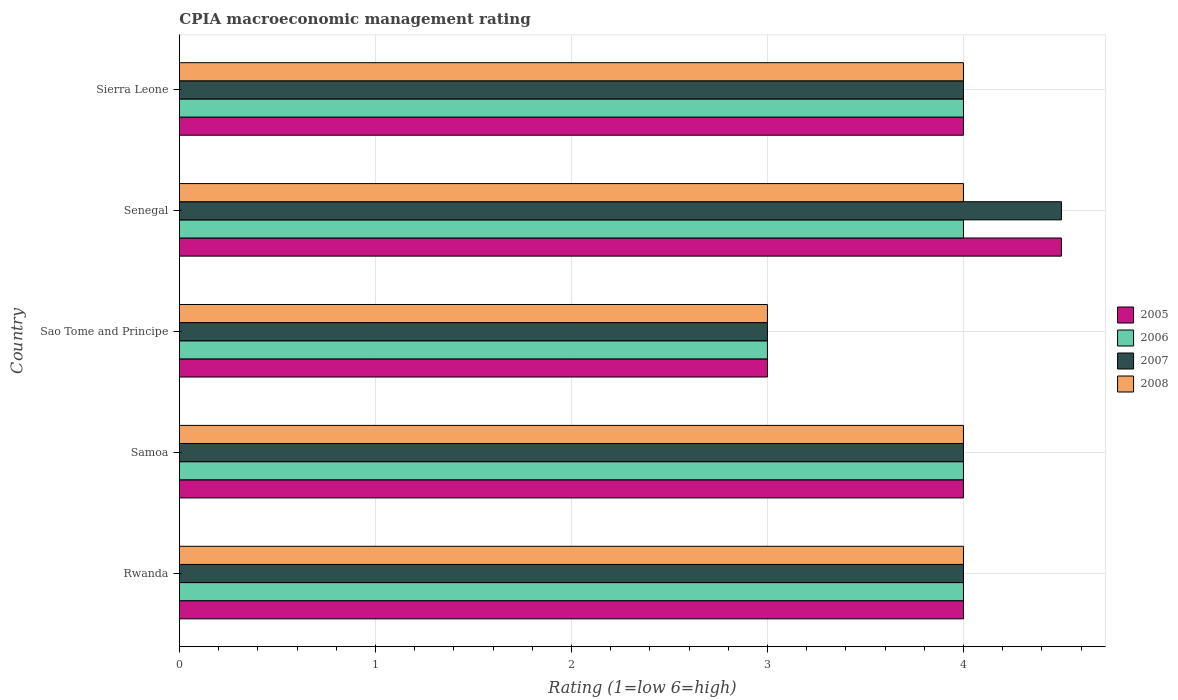How many different coloured bars are there?
Provide a short and direct response. 4. Are the number of bars per tick equal to the number of legend labels?
Your answer should be very brief. Yes. Are the number of bars on each tick of the Y-axis equal?
Your response must be concise. Yes. What is the label of the 3rd group of bars from the top?
Give a very brief answer. Sao Tome and Principe. In how many cases, is the number of bars for a given country not equal to the number of legend labels?
Your answer should be compact. 0. Across all countries, what is the maximum CPIA rating in 2007?
Your response must be concise. 4.5. In which country was the CPIA rating in 2006 maximum?
Keep it short and to the point. Rwanda. In which country was the CPIA rating in 2005 minimum?
Your answer should be very brief. Sao Tome and Principe. What is the difference between the CPIA rating in 2005 in Rwanda and that in Samoa?
Offer a terse response. 0. What is the difference between the CPIA rating in 2006 in Rwanda and the CPIA rating in 2007 in Senegal?
Offer a terse response. -0.5. In how many countries, is the CPIA rating in 2008 greater than 2.6 ?
Provide a succinct answer. 5. What is the ratio of the CPIA rating in 2006 in Sao Tome and Principe to that in Sierra Leone?
Your answer should be very brief. 0.75. Is the CPIA rating in 2007 in Rwanda less than that in Sao Tome and Principe?
Ensure brevity in your answer.  No. Is the difference between the CPIA rating in 2007 in Rwanda and Samoa greater than the difference between the CPIA rating in 2008 in Rwanda and Samoa?
Your response must be concise. No. What is the difference between the highest and the second highest CPIA rating in 2006?
Provide a short and direct response. 0. What is the difference between the highest and the lowest CPIA rating in 2007?
Ensure brevity in your answer.  1.5. In how many countries, is the CPIA rating in 2006 greater than the average CPIA rating in 2006 taken over all countries?
Provide a short and direct response. 4. Is the sum of the CPIA rating in 2008 in Samoa and Senegal greater than the maximum CPIA rating in 2005 across all countries?
Offer a very short reply. Yes. Is it the case that in every country, the sum of the CPIA rating in 2007 and CPIA rating in 2008 is greater than the sum of CPIA rating in 2006 and CPIA rating in 2005?
Offer a very short reply. No. What does the 1st bar from the top in Senegal represents?
Your answer should be very brief. 2008. What does the 2nd bar from the bottom in Senegal represents?
Give a very brief answer. 2006. Are all the bars in the graph horizontal?
Offer a very short reply. Yes. How many countries are there in the graph?
Keep it short and to the point. 5. What is the difference between two consecutive major ticks on the X-axis?
Give a very brief answer. 1. Does the graph contain grids?
Offer a very short reply. Yes. Where does the legend appear in the graph?
Offer a very short reply. Center right. How are the legend labels stacked?
Make the answer very short. Vertical. What is the title of the graph?
Your answer should be compact. CPIA macroeconomic management rating. Does "1988" appear as one of the legend labels in the graph?
Offer a very short reply. No. What is the Rating (1=low 6=high) in 2007 in Rwanda?
Provide a succinct answer. 4. What is the Rating (1=low 6=high) of 2005 in Sao Tome and Principe?
Provide a short and direct response. 3. What is the Rating (1=low 6=high) in 2006 in Sao Tome and Principe?
Offer a terse response. 3. What is the Rating (1=low 6=high) of 2007 in Sao Tome and Principe?
Provide a succinct answer. 3. What is the Rating (1=low 6=high) in 2008 in Sao Tome and Principe?
Offer a terse response. 3. What is the Rating (1=low 6=high) in 2007 in Senegal?
Your answer should be compact. 4.5. What is the Rating (1=low 6=high) of 2008 in Senegal?
Provide a succinct answer. 4. What is the Rating (1=low 6=high) in 2005 in Sierra Leone?
Keep it short and to the point. 4. What is the Rating (1=low 6=high) in 2006 in Sierra Leone?
Offer a terse response. 4. What is the Rating (1=low 6=high) of 2008 in Sierra Leone?
Keep it short and to the point. 4. Across all countries, what is the maximum Rating (1=low 6=high) of 2005?
Make the answer very short. 4.5. Across all countries, what is the maximum Rating (1=low 6=high) in 2007?
Keep it short and to the point. 4.5. Across all countries, what is the maximum Rating (1=low 6=high) in 2008?
Provide a succinct answer. 4. Across all countries, what is the minimum Rating (1=low 6=high) in 2005?
Provide a short and direct response. 3. Across all countries, what is the minimum Rating (1=low 6=high) in 2006?
Provide a short and direct response. 3. Across all countries, what is the minimum Rating (1=low 6=high) of 2007?
Offer a terse response. 3. What is the total Rating (1=low 6=high) of 2005 in the graph?
Offer a terse response. 19.5. What is the total Rating (1=low 6=high) in 2007 in the graph?
Ensure brevity in your answer.  19.5. What is the difference between the Rating (1=low 6=high) of 2006 in Rwanda and that in Samoa?
Make the answer very short. 0. What is the difference between the Rating (1=low 6=high) of 2007 in Rwanda and that in Samoa?
Your answer should be very brief. 0. What is the difference between the Rating (1=low 6=high) in 2006 in Rwanda and that in Sao Tome and Principe?
Your answer should be compact. 1. What is the difference between the Rating (1=low 6=high) of 2006 in Rwanda and that in Senegal?
Provide a short and direct response. 0. What is the difference between the Rating (1=low 6=high) in 2007 in Rwanda and that in Senegal?
Your answer should be very brief. -0.5. What is the difference between the Rating (1=low 6=high) of 2006 in Rwanda and that in Sierra Leone?
Your answer should be compact. 0. What is the difference between the Rating (1=low 6=high) in 2008 in Rwanda and that in Sierra Leone?
Ensure brevity in your answer.  0. What is the difference between the Rating (1=low 6=high) in 2005 in Samoa and that in Senegal?
Give a very brief answer. -0.5. What is the difference between the Rating (1=low 6=high) in 2005 in Samoa and that in Sierra Leone?
Your answer should be compact. 0. What is the difference between the Rating (1=low 6=high) of 2006 in Samoa and that in Sierra Leone?
Provide a succinct answer. 0. What is the difference between the Rating (1=low 6=high) of 2008 in Samoa and that in Sierra Leone?
Offer a very short reply. 0. What is the difference between the Rating (1=low 6=high) of 2005 in Sao Tome and Principe and that in Senegal?
Give a very brief answer. -1.5. What is the difference between the Rating (1=low 6=high) in 2008 in Sao Tome and Principe and that in Senegal?
Your response must be concise. -1. What is the difference between the Rating (1=low 6=high) in 2005 in Sao Tome and Principe and that in Sierra Leone?
Keep it short and to the point. -1. What is the difference between the Rating (1=low 6=high) of 2006 in Sao Tome and Principe and that in Sierra Leone?
Ensure brevity in your answer.  -1. What is the difference between the Rating (1=low 6=high) in 2006 in Senegal and that in Sierra Leone?
Offer a terse response. 0. What is the difference between the Rating (1=low 6=high) in 2007 in Senegal and that in Sierra Leone?
Your answer should be very brief. 0.5. What is the difference between the Rating (1=low 6=high) in 2008 in Senegal and that in Sierra Leone?
Offer a terse response. 0. What is the difference between the Rating (1=low 6=high) in 2005 in Rwanda and the Rating (1=low 6=high) in 2006 in Samoa?
Your answer should be compact. 0. What is the difference between the Rating (1=low 6=high) in 2005 in Rwanda and the Rating (1=low 6=high) in 2007 in Samoa?
Offer a terse response. 0. What is the difference between the Rating (1=low 6=high) of 2005 in Rwanda and the Rating (1=low 6=high) of 2008 in Samoa?
Provide a succinct answer. 0. What is the difference between the Rating (1=low 6=high) of 2006 in Rwanda and the Rating (1=low 6=high) of 2007 in Samoa?
Provide a short and direct response. 0. What is the difference between the Rating (1=low 6=high) of 2007 in Rwanda and the Rating (1=low 6=high) of 2008 in Samoa?
Provide a succinct answer. 0. What is the difference between the Rating (1=low 6=high) in 2005 in Rwanda and the Rating (1=low 6=high) in 2007 in Sao Tome and Principe?
Provide a succinct answer. 1. What is the difference between the Rating (1=low 6=high) in 2005 in Rwanda and the Rating (1=low 6=high) in 2008 in Sao Tome and Principe?
Your answer should be very brief. 1. What is the difference between the Rating (1=low 6=high) in 2006 in Rwanda and the Rating (1=low 6=high) in 2007 in Sao Tome and Principe?
Offer a very short reply. 1. What is the difference between the Rating (1=low 6=high) of 2006 in Rwanda and the Rating (1=low 6=high) of 2008 in Sao Tome and Principe?
Your answer should be compact. 1. What is the difference between the Rating (1=low 6=high) of 2005 in Rwanda and the Rating (1=low 6=high) of 2006 in Senegal?
Ensure brevity in your answer.  0. What is the difference between the Rating (1=low 6=high) of 2007 in Rwanda and the Rating (1=low 6=high) of 2008 in Senegal?
Keep it short and to the point. 0. What is the difference between the Rating (1=low 6=high) in 2005 in Rwanda and the Rating (1=low 6=high) in 2007 in Sierra Leone?
Offer a very short reply. 0. What is the difference between the Rating (1=low 6=high) of 2005 in Rwanda and the Rating (1=low 6=high) of 2008 in Sierra Leone?
Give a very brief answer. 0. What is the difference between the Rating (1=low 6=high) in 2006 in Rwanda and the Rating (1=low 6=high) in 2008 in Sierra Leone?
Your answer should be compact. 0. What is the difference between the Rating (1=low 6=high) of 2005 in Samoa and the Rating (1=low 6=high) of 2007 in Sao Tome and Principe?
Your answer should be compact. 1. What is the difference between the Rating (1=low 6=high) in 2006 in Samoa and the Rating (1=low 6=high) in 2007 in Sao Tome and Principe?
Your response must be concise. 1. What is the difference between the Rating (1=low 6=high) in 2007 in Samoa and the Rating (1=low 6=high) in 2008 in Sao Tome and Principe?
Ensure brevity in your answer.  1. What is the difference between the Rating (1=low 6=high) of 2005 in Samoa and the Rating (1=low 6=high) of 2006 in Senegal?
Provide a short and direct response. 0. What is the difference between the Rating (1=low 6=high) of 2006 in Samoa and the Rating (1=low 6=high) of 2007 in Senegal?
Ensure brevity in your answer.  -0.5. What is the difference between the Rating (1=low 6=high) in 2005 in Samoa and the Rating (1=low 6=high) in 2006 in Sierra Leone?
Your answer should be compact. 0. What is the difference between the Rating (1=low 6=high) in 2005 in Samoa and the Rating (1=low 6=high) in 2007 in Sierra Leone?
Provide a short and direct response. 0. What is the difference between the Rating (1=low 6=high) in 2005 in Samoa and the Rating (1=low 6=high) in 2008 in Sierra Leone?
Make the answer very short. 0. What is the difference between the Rating (1=low 6=high) of 2006 in Samoa and the Rating (1=low 6=high) of 2007 in Sierra Leone?
Make the answer very short. 0. What is the difference between the Rating (1=low 6=high) of 2006 in Samoa and the Rating (1=low 6=high) of 2008 in Sierra Leone?
Your response must be concise. 0. What is the difference between the Rating (1=low 6=high) in 2005 in Sao Tome and Principe and the Rating (1=low 6=high) in 2006 in Senegal?
Your response must be concise. -1. What is the difference between the Rating (1=low 6=high) in 2005 in Sao Tome and Principe and the Rating (1=low 6=high) in 2008 in Senegal?
Make the answer very short. -1. What is the difference between the Rating (1=low 6=high) of 2006 in Sao Tome and Principe and the Rating (1=low 6=high) of 2008 in Senegal?
Give a very brief answer. -1. What is the difference between the Rating (1=low 6=high) in 2006 in Sao Tome and Principe and the Rating (1=low 6=high) in 2007 in Sierra Leone?
Your answer should be compact. -1. What is the difference between the Rating (1=low 6=high) in 2007 in Sao Tome and Principe and the Rating (1=low 6=high) in 2008 in Sierra Leone?
Your answer should be compact. -1. What is the difference between the Rating (1=low 6=high) of 2005 in Senegal and the Rating (1=low 6=high) of 2007 in Sierra Leone?
Your response must be concise. 0.5. What is the difference between the Rating (1=low 6=high) of 2007 in Senegal and the Rating (1=low 6=high) of 2008 in Sierra Leone?
Your response must be concise. 0.5. What is the average Rating (1=low 6=high) of 2005 per country?
Ensure brevity in your answer.  3.9. What is the average Rating (1=low 6=high) in 2006 per country?
Offer a very short reply. 3.8. What is the difference between the Rating (1=low 6=high) of 2005 and Rating (1=low 6=high) of 2008 in Rwanda?
Offer a very short reply. 0. What is the difference between the Rating (1=low 6=high) in 2006 and Rating (1=low 6=high) in 2007 in Rwanda?
Make the answer very short. 0. What is the difference between the Rating (1=low 6=high) in 2005 and Rating (1=low 6=high) in 2006 in Samoa?
Your answer should be compact. 0. What is the difference between the Rating (1=low 6=high) of 2007 and Rating (1=low 6=high) of 2008 in Samoa?
Keep it short and to the point. 0. What is the difference between the Rating (1=low 6=high) of 2005 and Rating (1=low 6=high) of 2006 in Senegal?
Offer a terse response. 0.5. What is the difference between the Rating (1=low 6=high) of 2005 and Rating (1=low 6=high) of 2007 in Senegal?
Ensure brevity in your answer.  0. What is the difference between the Rating (1=low 6=high) in 2006 and Rating (1=low 6=high) in 2007 in Senegal?
Offer a very short reply. -0.5. What is the difference between the Rating (1=low 6=high) of 2006 and Rating (1=low 6=high) of 2008 in Senegal?
Provide a succinct answer. 0. What is the difference between the Rating (1=low 6=high) of 2007 and Rating (1=low 6=high) of 2008 in Senegal?
Provide a short and direct response. 0.5. What is the difference between the Rating (1=low 6=high) of 2005 and Rating (1=low 6=high) of 2008 in Sierra Leone?
Give a very brief answer. 0. What is the difference between the Rating (1=low 6=high) in 2006 and Rating (1=low 6=high) in 2008 in Sierra Leone?
Make the answer very short. 0. What is the difference between the Rating (1=low 6=high) of 2007 and Rating (1=low 6=high) of 2008 in Sierra Leone?
Make the answer very short. 0. What is the ratio of the Rating (1=low 6=high) in 2007 in Rwanda to that in Samoa?
Give a very brief answer. 1. What is the ratio of the Rating (1=low 6=high) of 2008 in Rwanda to that in Samoa?
Offer a very short reply. 1. What is the ratio of the Rating (1=low 6=high) of 2005 in Rwanda to that in Sao Tome and Principe?
Keep it short and to the point. 1.33. What is the ratio of the Rating (1=low 6=high) of 2007 in Rwanda to that in Sao Tome and Principe?
Your response must be concise. 1.33. What is the ratio of the Rating (1=low 6=high) in 2008 in Rwanda to that in Sao Tome and Principe?
Your answer should be very brief. 1.33. What is the ratio of the Rating (1=low 6=high) of 2005 in Rwanda to that in Senegal?
Keep it short and to the point. 0.89. What is the ratio of the Rating (1=low 6=high) of 2006 in Rwanda to that in Senegal?
Your answer should be very brief. 1. What is the ratio of the Rating (1=low 6=high) of 2008 in Samoa to that in Sao Tome and Principe?
Your response must be concise. 1.33. What is the ratio of the Rating (1=low 6=high) of 2005 in Samoa to that in Senegal?
Provide a succinct answer. 0.89. What is the ratio of the Rating (1=low 6=high) of 2006 in Samoa to that in Sierra Leone?
Give a very brief answer. 1. What is the ratio of the Rating (1=low 6=high) in 2008 in Samoa to that in Sierra Leone?
Make the answer very short. 1. What is the ratio of the Rating (1=low 6=high) of 2006 in Sao Tome and Principe to that in Senegal?
Your answer should be compact. 0.75. What is the ratio of the Rating (1=low 6=high) of 2008 in Sao Tome and Principe to that in Senegal?
Your response must be concise. 0.75. What is the ratio of the Rating (1=low 6=high) in 2005 in Sao Tome and Principe to that in Sierra Leone?
Your response must be concise. 0.75. What is the ratio of the Rating (1=low 6=high) in 2006 in Sao Tome and Principe to that in Sierra Leone?
Give a very brief answer. 0.75. What is the ratio of the Rating (1=low 6=high) of 2008 in Sao Tome and Principe to that in Sierra Leone?
Make the answer very short. 0.75. What is the ratio of the Rating (1=low 6=high) of 2006 in Senegal to that in Sierra Leone?
Your answer should be very brief. 1. What is the ratio of the Rating (1=low 6=high) of 2007 in Senegal to that in Sierra Leone?
Provide a short and direct response. 1.12. What is the ratio of the Rating (1=low 6=high) in 2008 in Senegal to that in Sierra Leone?
Offer a very short reply. 1. What is the difference between the highest and the second highest Rating (1=low 6=high) in 2005?
Keep it short and to the point. 0.5. What is the difference between the highest and the lowest Rating (1=low 6=high) of 2006?
Give a very brief answer. 1. 